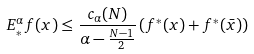<formula> <loc_0><loc_0><loc_500><loc_500>E _ { * } ^ { \alpha } f ( x ) \leq \frac { c _ { \alpha } ( N ) } { \alpha - \frac { N - 1 } { 2 } } \left ( f ^ { * } ( x ) + f ^ { * } ( \bar { x } ) \right )</formula> 